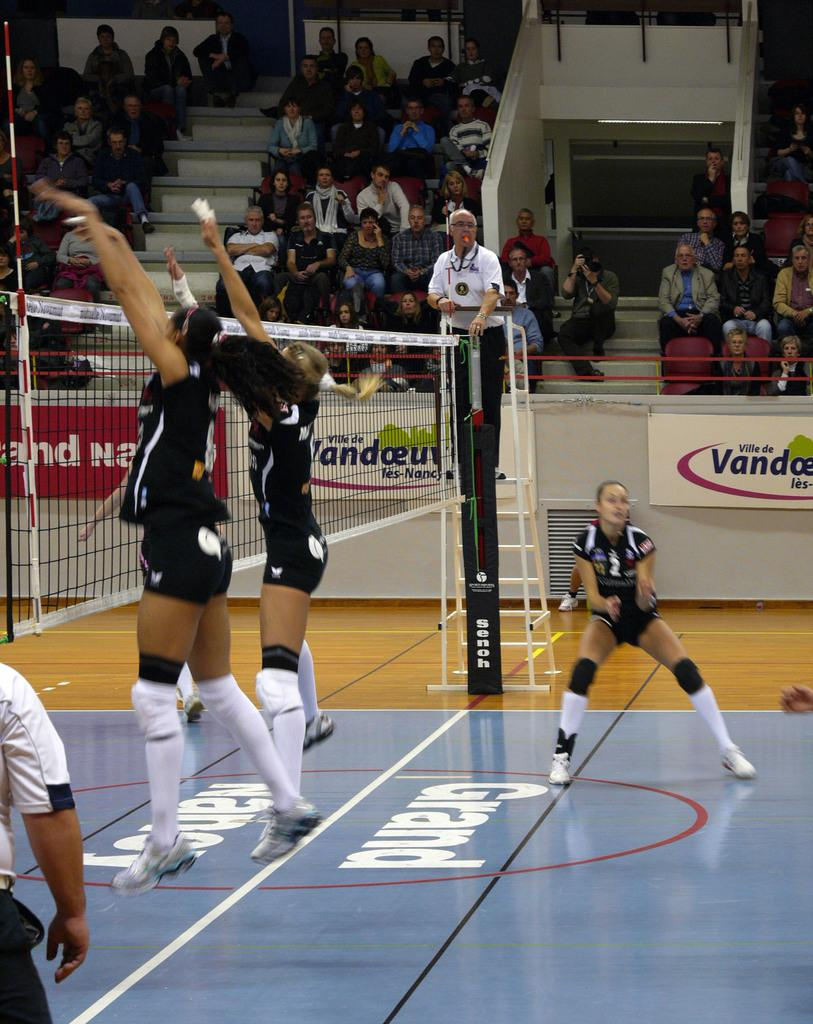Provide a one-sentence caption for the provided image. Girls play volleyball on mats labeled with the word Grand. 